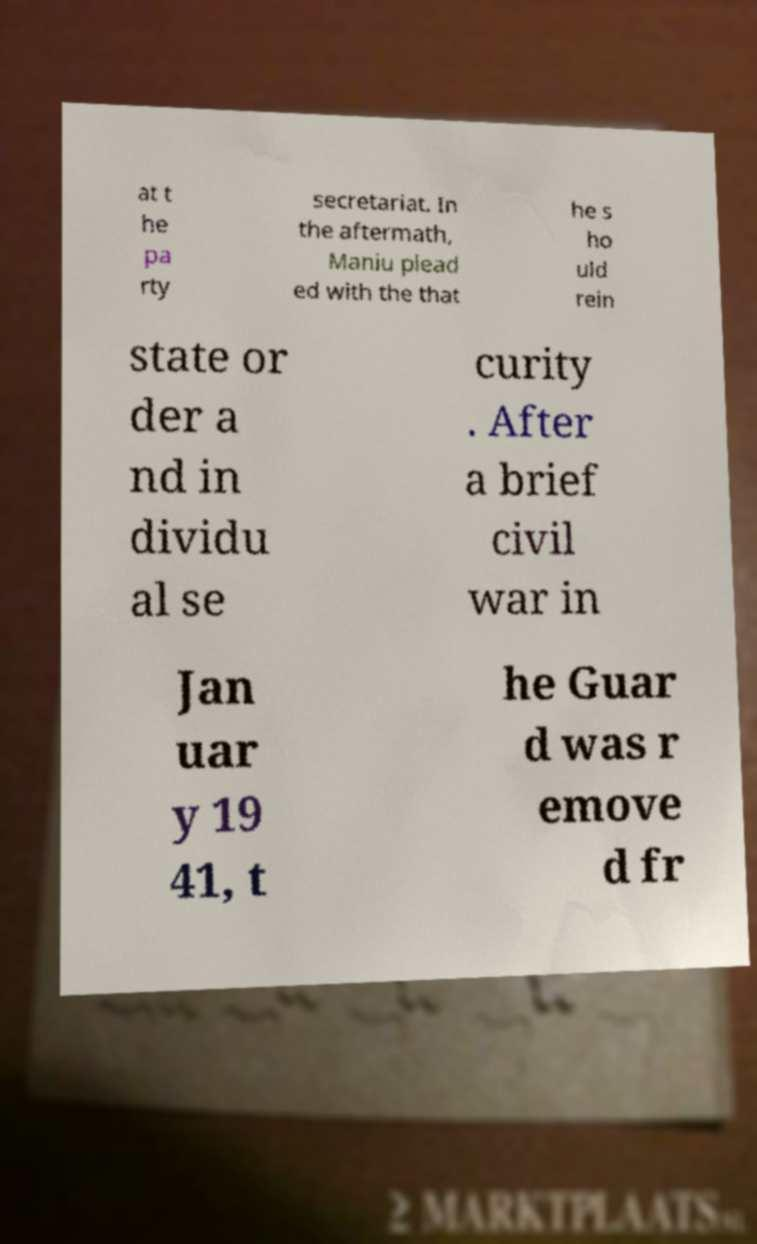Please read and relay the text visible in this image. What does it say? at t he pa rty secretariat. In the aftermath, Maniu plead ed with the that he s ho uld rein state or der a nd in dividu al se curity . After a brief civil war in Jan uar y 19 41, t he Guar d was r emove d fr 